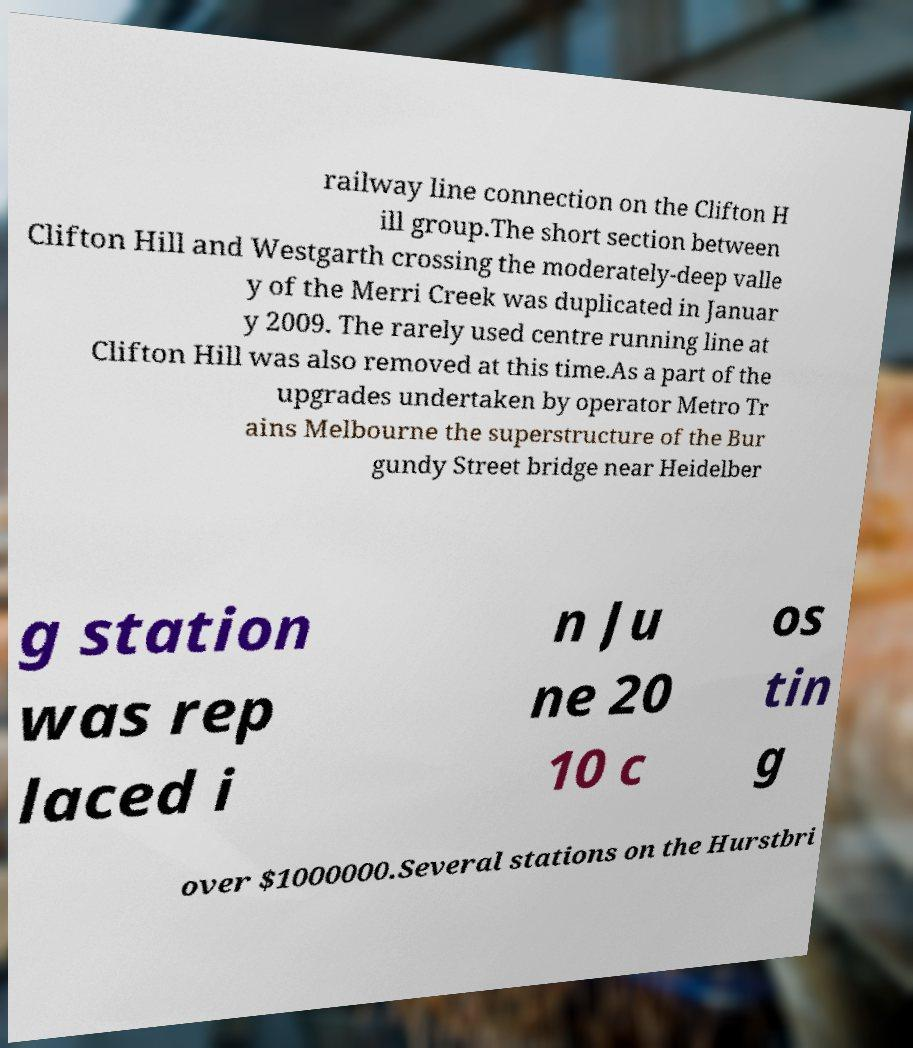Could you extract and type out the text from this image? railway line connection on the Clifton H ill group.The short section between Clifton Hill and Westgarth crossing the moderately-deep valle y of the Merri Creek was duplicated in Januar y 2009. The rarely used centre running line at Clifton Hill was also removed at this time.As a part of the upgrades undertaken by operator Metro Tr ains Melbourne the superstructure of the Bur gundy Street bridge near Heidelber g station was rep laced i n Ju ne 20 10 c os tin g over $1000000.Several stations on the Hurstbri 